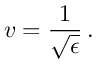Convert formula to latex. <formula><loc_0><loc_0><loc_500><loc_500>v = { \frac { 1 } { \sqrt { \epsilon } } } \, .</formula> 